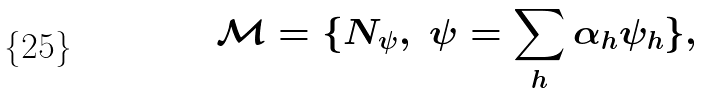Convert formula to latex. <formula><loc_0><loc_0><loc_500><loc_500>\mathcal { M } = \{ N _ { \psi } , \ \psi = \sum _ { h } \alpha _ { h } \psi _ { h } \} ,</formula> 